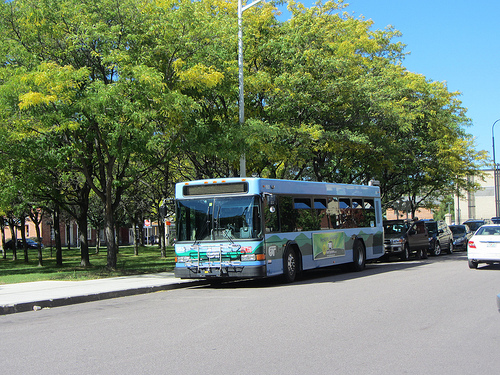What is in front of the street light? The bus is in front of the street light. 